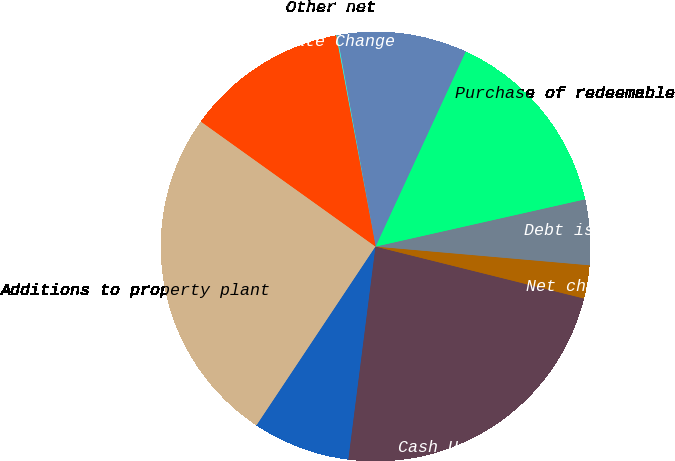<chart> <loc_0><loc_0><loc_500><loc_500><pie_chart><fcel>Additions to property plant<fcel>Purchases of marketable<fcel>Cash Used for Investing<fcel>Net change in debt<fcel>Debt issuance costs<fcel>Purchase of redeemable<fcel>Purchases of Tyson Class A<fcel>Other net<fcel>Effect of Exchange Rate Change<nl><fcel>25.54%<fcel>7.33%<fcel>23.13%<fcel>2.5%<fcel>4.92%<fcel>14.58%<fcel>9.75%<fcel>0.08%<fcel>12.17%<nl></chart> 